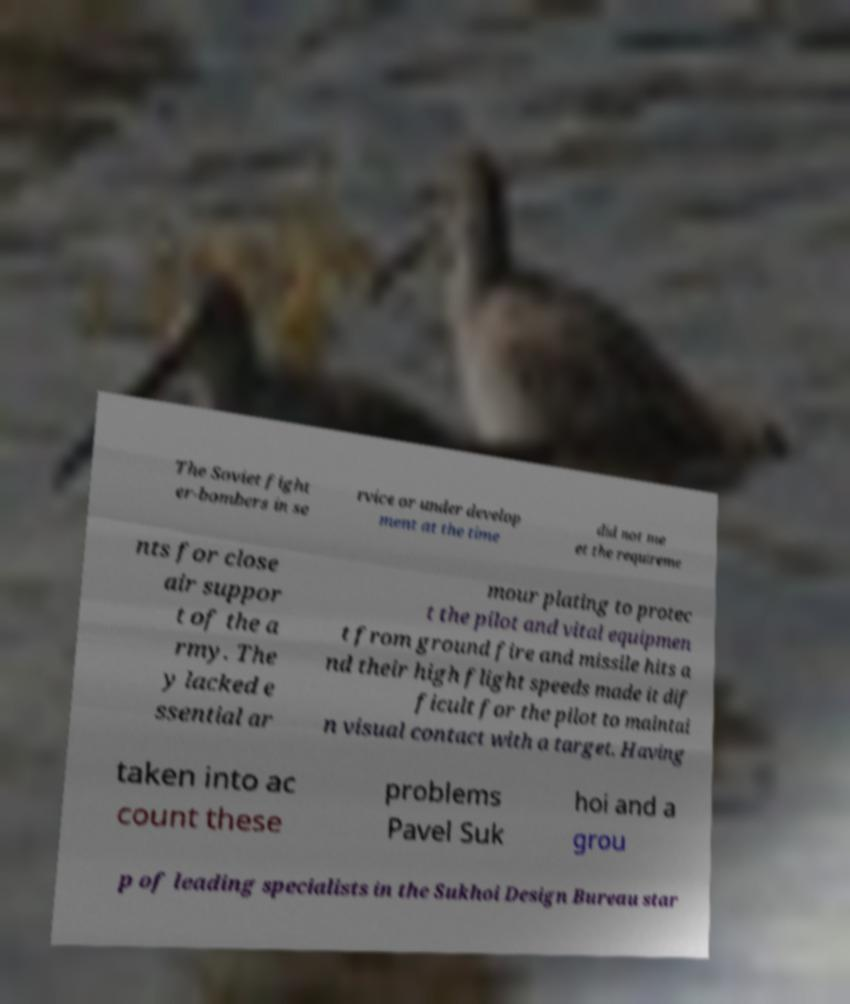Can you accurately transcribe the text from the provided image for me? The Soviet fight er-bombers in se rvice or under develop ment at the time did not me et the requireme nts for close air suppor t of the a rmy. The y lacked e ssential ar mour plating to protec t the pilot and vital equipmen t from ground fire and missile hits a nd their high flight speeds made it dif ficult for the pilot to maintai n visual contact with a target. Having taken into ac count these problems Pavel Suk hoi and a grou p of leading specialists in the Sukhoi Design Bureau star 